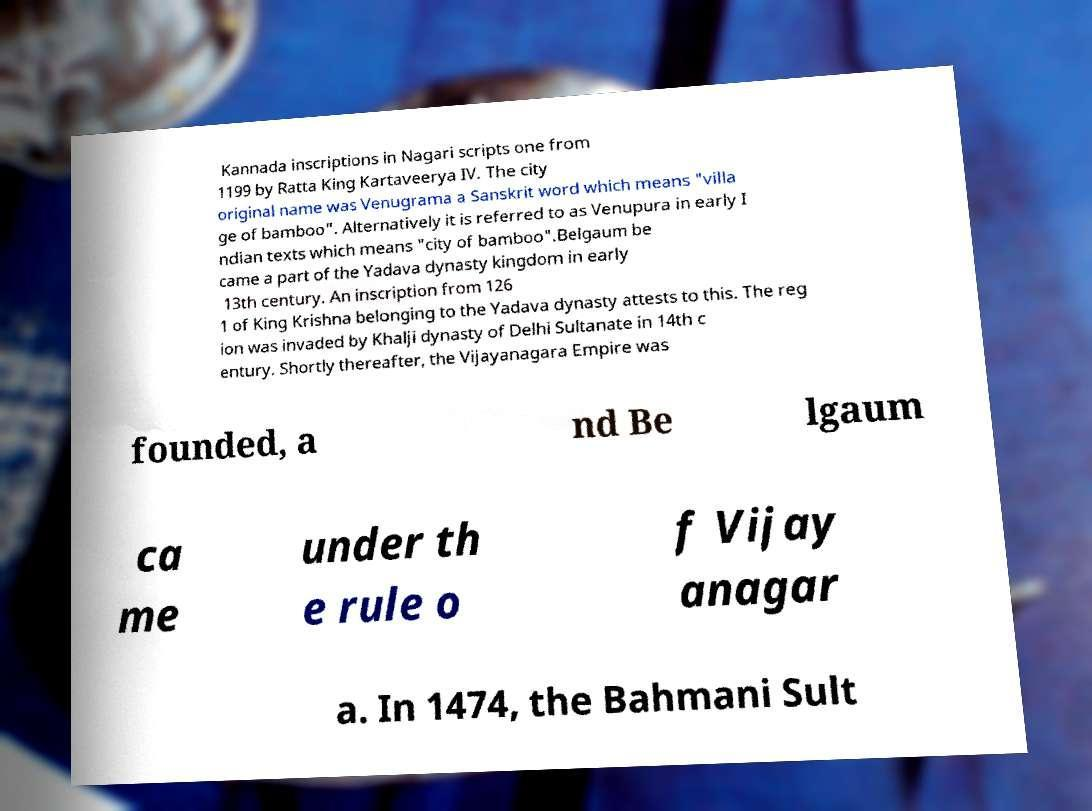Please identify and transcribe the text found in this image. Kannada inscriptions in Nagari scripts one from 1199 by Ratta King Kartaveerya IV. The city original name was Venugrama a Sanskrit word which means "villa ge of bamboo". Alternatively it is referred to as Venupura in early I ndian texts which means "city of bamboo".Belgaum be came a part of the Yadava dynasty kingdom in early 13th century. An inscription from 126 1 of King Krishna belonging to the Yadava dynasty attests to this. The reg ion was invaded by Khalji dynasty of Delhi Sultanate in 14th c entury. Shortly thereafter, the Vijayanagara Empire was founded, a nd Be lgaum ca me under th e rule o f Vijay anagar a. In 1474, the Bahmani Sult 